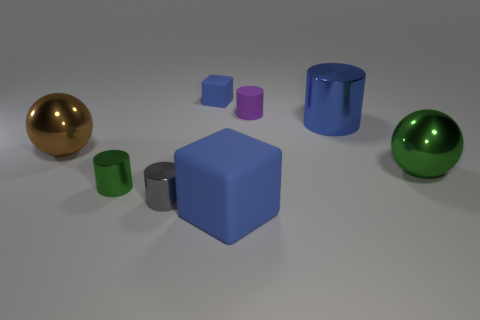What number of objects are on the left side of the green shiny ball and behind the gray shiny cylinder? There are no objects to the left of the green shiny ball and behind the gray shiny cylinder. All objects are either to the right or in front of the gray shiny cylinder when viewed from the current perspective. 